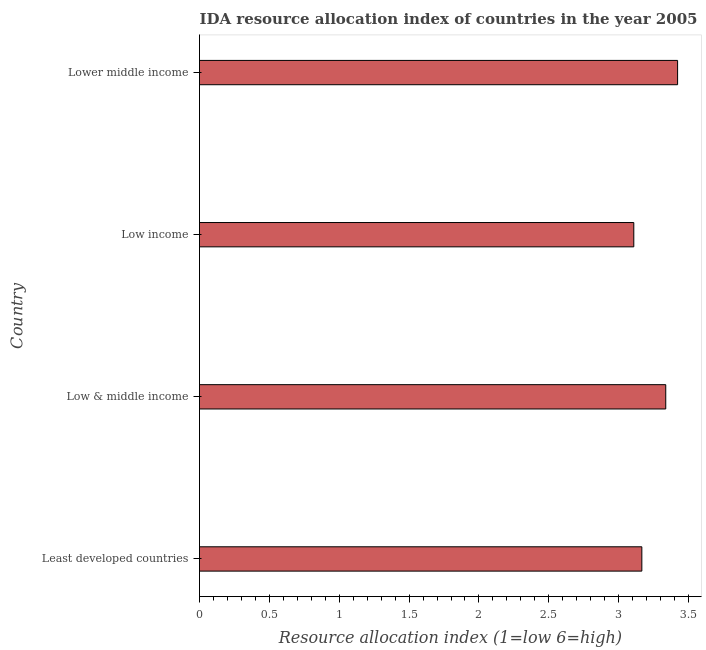Does the graph contain any zero values?
Ensure brevity in your answer.  No. Does the graph contain grids?
Your response must be concise. No. What is the title of the graph?
Offer a terse response. IDA resource allocation index of countries in the year 2005. What is the label or title of the X-axis?
Give a very brief answer. Resource allocation index (1=low 6=high). What is the label or title of the Y-axis?
Provide a succinct answer. Country. What is the ida resource allocation index in Lower middle income?
Ensure brevity in your answer.  3.42. Across all countries, what is the maximum ida resource allocation index?
Your answer should be compact. 3.42. Across all countries, what is the minimum ida resource allocation index?
Make the answer very short. 3.11. In which country was the ida resource allocation index maximum?
Your response must be concise. Lower middle income. What is the sum of the ida resource allocation index?
Offer a terse response. 13.03. What is the difference between the ida resource allocation index in Low & middle income and Lower middle income?
Ensure brevity in your answer.  -0.09. What is the average ida resource allocation index per country?
Keep it short and to the point. 3.26. What is the median ida resource allocation index?
Offer a terse response. 3.25. What is the ratio of the ida resource allocation index in Low & middle income to that in Lower middle income?
Provide a succinct answer. 0.97. Is the ida resource allocation index in Least developed countries less than that in Low income?
Ensure brevity in your answer.  No. What is the difference between the highest and the second highest ida resource allocation index?
Make the answer very short. 0.09. Is the sum of the ida resource allocation index in Low & middle income and Lower middle income greater than the maximum ida resource allocation index across all countries?
Provide a succinct answer. Yes. What is the difference between the highest and the lowest ida resource allocation index?
Offer a very short reply. 0.31. How many bars are there?
Keep it short and to the point. 4. How many countries are there in the graph?
Give a very brief answer. 4. What is the Resource allocation index (1=low 6=high) in Least developed countries?
Your answer should be very brief. 3.17. What is the Resource allocation index (1=low 6=high) of Low & middle income?
Provide a short and direct response. 3.34. What is the Resource allocation index (1=low 6=high) of Low income?
Your response must be concise. 3.11. What is the Resource allocation index (1=low 6=high) in Lower middle income?
Your response must be concise. 3.42. What is the difference between the Resource allocation index (1=low 6=high) in Least developed countries and Low & middle income?
Provide a succinct answer. -0.17. What is the difference between the Resource allocation index (1=low 6=high) in Least developed countries and Low income?
Make the answer very short. 0.06. What is the difference between the Resource allocation index (1=low 6=high) in Least developed countries and Lower middle income?
Give a very brief answer. -0.26. What is the difference between the Resource allocation index (1=low 6=high) in Low & middle income and Low income?
Keep it short and to the point. 0.23. What is the difference between the Resource allocation index (1=low 6=high) in Low & middle income and Lower middle income?
Provide a short and direct response. -0.08. What is the difference between the Resource allocation index (1=low 6=high) in Low income and Lower middle income?
Your response must be concise. -0.31. What is the ratio of the Resource allocation index (1=low 6=high) in Least developed countries to that in Low & middle income?
Your answer should be very brief. 0.95. What is the ratio of the Resource allocation index (1=low 6=high) in Least developed countries to that in Low income?
Provide a succinct answer. 1.02. What is the ratio of the Resource allocation index (1=low 6=high) in Least developed countries to that in Lower middle income?
Your answer should be very brief. 0.93. What is the ratio of the Resource allocation index (1=low 6=high) in Low & middle income to that in Low income?
Ensure brevity in your answer.  1.07. What is the ratio of the Resource allocation index (1=low 6=high) in Low & middle income to that in Lower middle income?
Make the answer very short. 0.97. What is the ratio of the Resource allocation index (1=low 6=high) in Low income to that in Lower middle income?
Offer a very short reply. 0.91. 